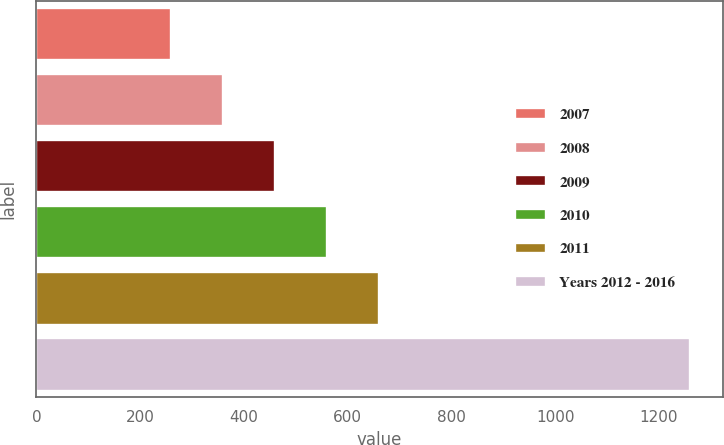Convert chart to OTSL. <chart><loc_0><loc_0><loc_500><loc_500><bar_chart><fcel>2007<fcel>2008<fcel>2009<fcel>2010<fcel>2011<fcel>Years 2012 - 2016<nl><fcel>260<fcel>360<fcel>460<fcel>560<fcel>660<fcel>1260<nl></chart> 